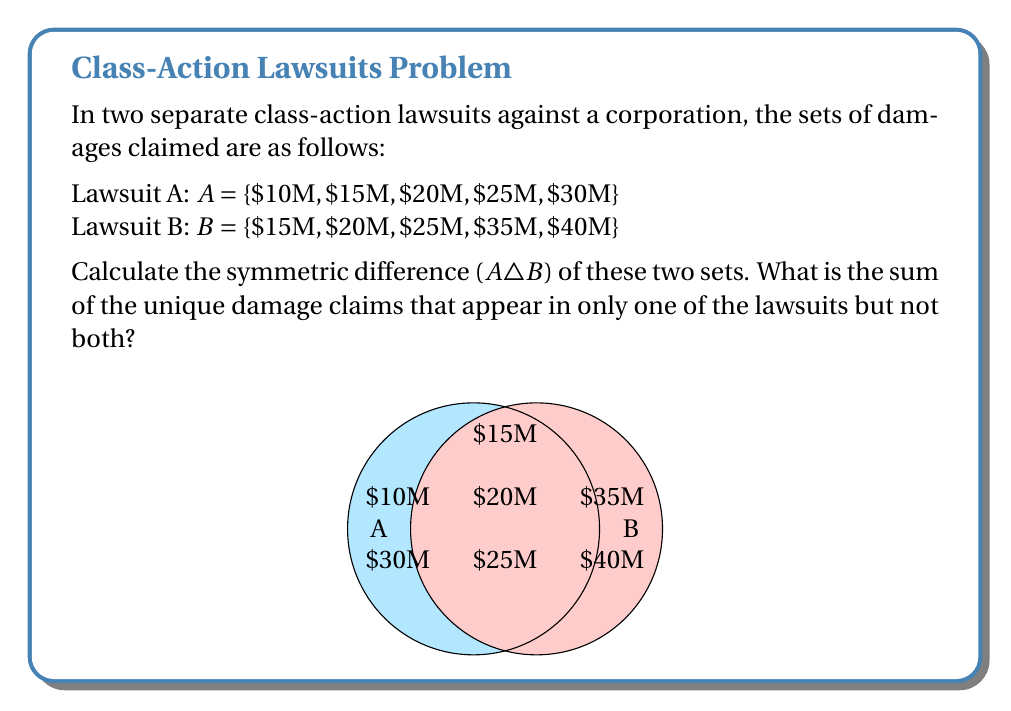Can you solve this math problem? To solve this problem, we'll follow these steps:

1) First, let's identify the elements in each set:
   $A = \{$10M, $15M, $20M, $25M, $30M\}$
   $B = \{$15M, $20M, $25M, $35M, $40M\}$

2) The symmetric difference $A \triangle B$ is defined as the set of elements that are in either A or B, but not in both. It can be expressed as $(A \setminus B) \cup (B \setminus A)$.

3) Let's find $A \setminus B$ (elements in A but not in B):
   $A \setminus B = \{$10M, $30M\}$

4) Now, let's find $B \setminus A$ (elements in B but not in A):
   $B \setminus A = \{$35M, $40M\}$

5) The symmetric difference is the union of these:
   $A \triangle B = \{$10M, $30M, $35M, $40M\}$

6) To find the sum of these unique damage claims, we add:
   $10M + $30M + $35M + $40M = $115M$

Therefore, the sum of the unique damage claims that appear in only one of the lawsuits is $115 million.
Answer: $115 million 